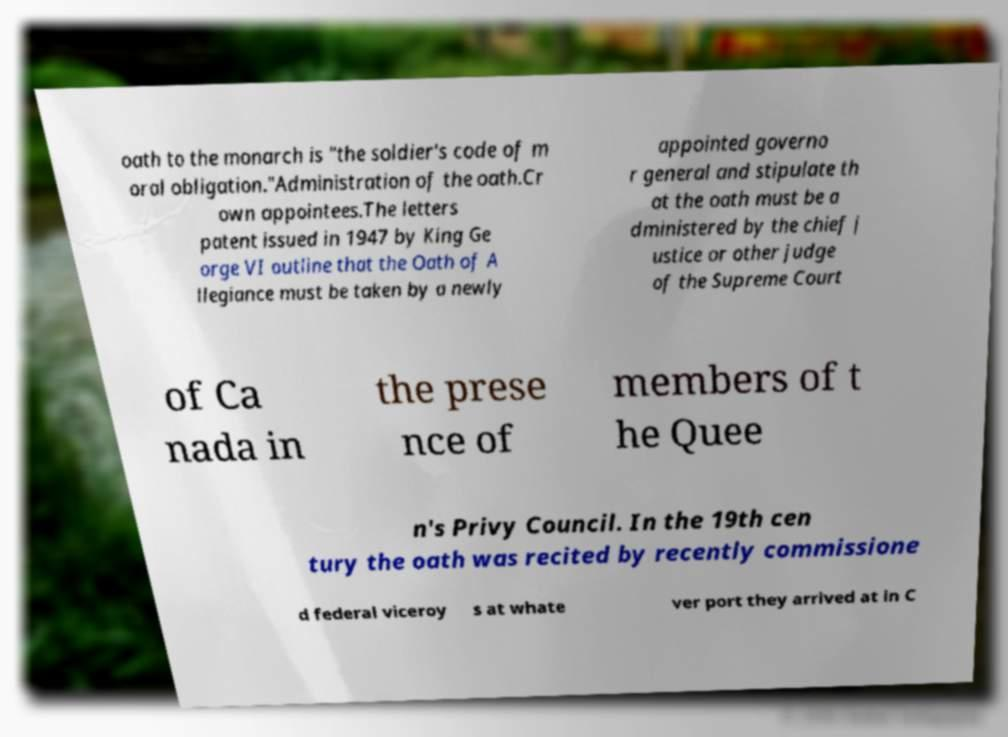Can you read and provide the text displayed in the image?This photo seems to have some interesting text. Can you extract and type it out for me? oath to the monarch is "the soldier's code of m oral obligation."Administration of the oath.Cr own appointees.The letters patent issued in 1947 by King Ge orge VI outline that the Oath of A llegiance must be taken by a newly appointed governo r general and stipulate th at the oath must be a dministered by the chief j ustice or other judge of the Supreme Court of Ca nada in the prese nce of members of t he Quee n's Privy Council. In the 19th cen tury the oath was recited by recently commissione d federal viceroy s at whate ver port they arrived at in C 